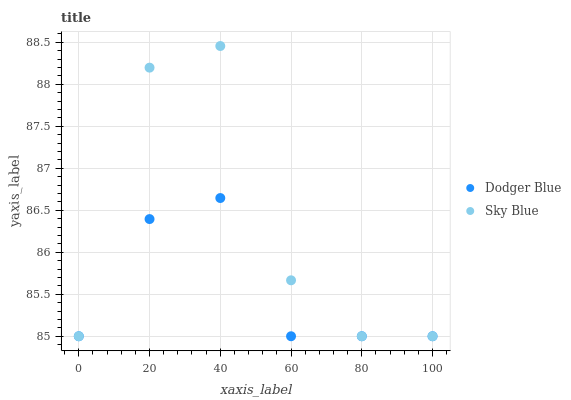Does Dodger Blue have the minimum area under the curve?
Answer yes or no. Yes. Does Sky Blue have the maximum area under the curve?
Answer yes or no. Yes. Does Dodger Blue have the maximum area under the curve?
Answer yes or no. No. Is Dodger Blue the smoothest?
Answer yes or no. Yes. Is Sky Blue the roughest?
Answer yes or no. Yes. Is Dodger Blue the roughest?
Answer yes or no. No. Does Sky Blue have the lowest value?
Answer yes or no. Yes. Does Sky Blue have the highest value?
Answer yes or no. Yes. Does Dodger Blue have the highest value?
Answer yes or no. No. Does Sky Blue intersect Dodger Blue?
Answer yes or no. Yes. Is Sky Blue less than Dodger Blue?
Answer yes or no. No. Is Sky Blue greater than Dodger Blue?
Answer yes or no. No. 